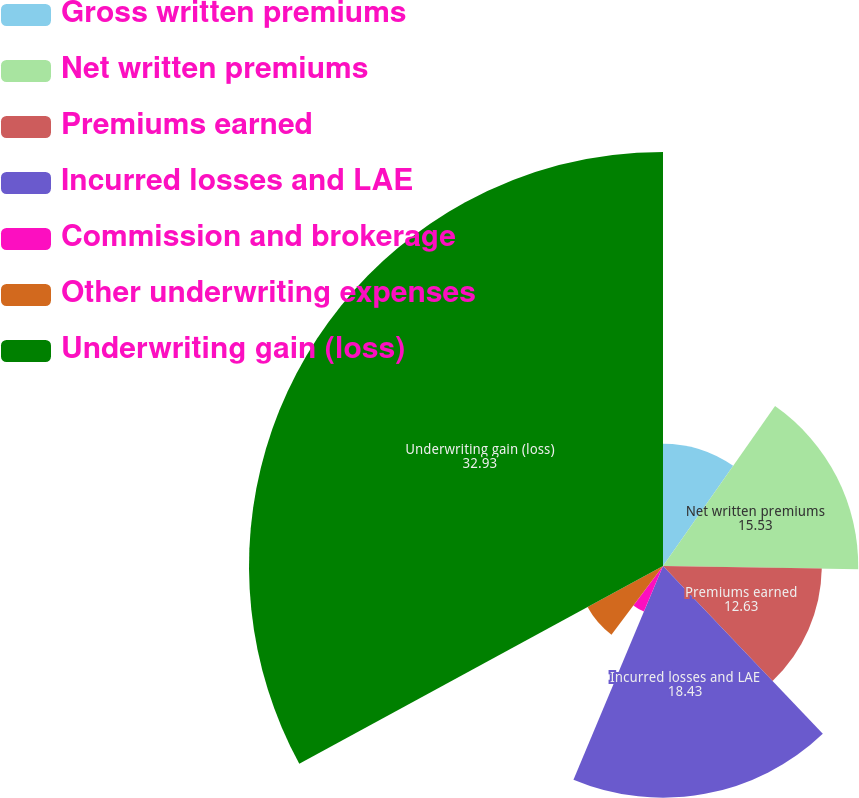Convert chart to OTSL. <chart><loc_0><loc_0><loc_500><loc_500><pie_chart><fcel>Gross written premiums<fcel>Net written premiums<fcel>Premiums earned<fcel>Incurred losses and LAE<fcel>Commission and brokerage<fcel>Other underwriting expenses<fcel>Underwriting gain (loss)<nl><fcel>9.73%<fcel>15.53%<fcel>12.63%<fcel>18.43%<fcel>3.93%<fcel>6.83%<fcel>32.93%<nl></chart> 